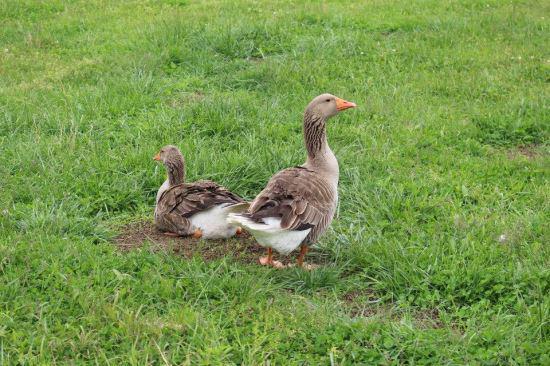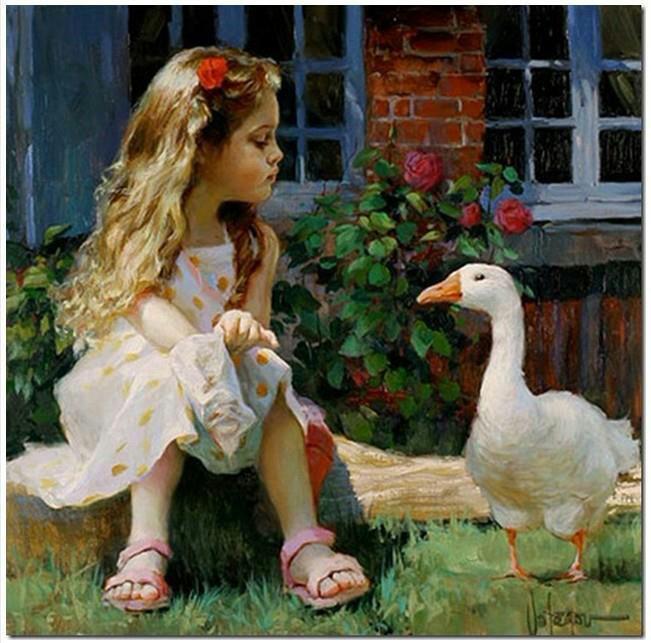The first image is the image on the left, the second image is the image on the right. Examine the images to the left and right. Is the description "An image contains a goose attacking a child." accurate? Answer yes or no. No. The first image is the image on the left, the second image is the image on the right. For the images shown, is this caption "The left image shows a child running near a white goose with wings spread, and the right image shows a girl in a dress holding something and standing by multiple geese." true? Answer yes or no. No. The first image is the image on the left, the second image is the image on the right. Analyze the images presented: Is the assertion "This a goose white white belly trying to bite a small scared child." valid? Answer yes or no. No. 